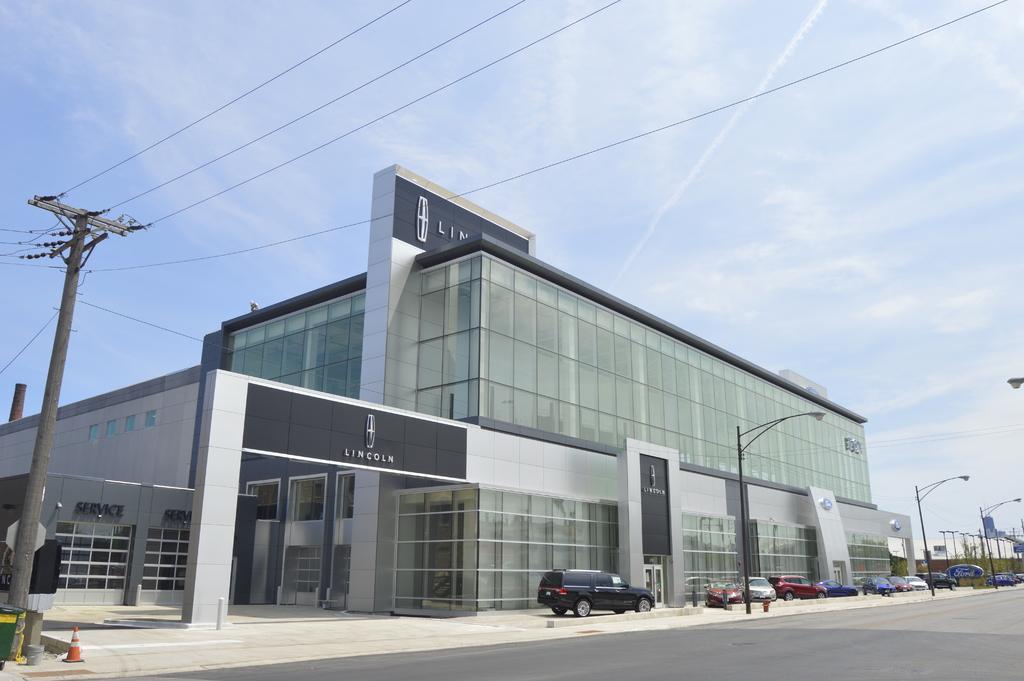Please provide a concise description of this image. This image is taken outdoors. At the bottom of the image there is a road. At the top of the image there is a sky with clouds. In the middle of the image a few cars are parked on the floor. There are a few street lights and there is a building. There are a few boards with text on them. On the left side of the image there is a pole with a few wires. 